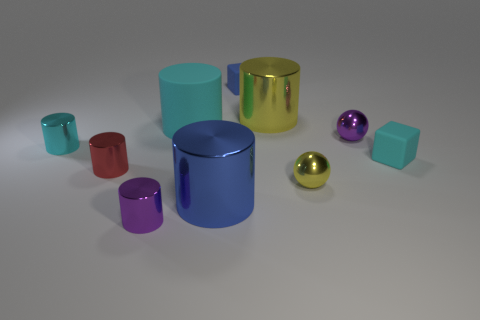There is a large matte cylinder; is it the same color as the small cylinder behind the cyan rubber cube?
Offer a terse response. Yes. Do the blue rubber block and the yellow cylinder have the same size?
Provide a succinct answer. No. There is a tiny yellow thing that is the same material as the tiny purple sphere; what shape is it?
Your answer should be compact. Sphere. What number of other things are there of the same shape as the blue matte thing?
Provide a succinct answer. 1. There is a small purple metal object that is to the left of the small purple object that is right of the small purple thing that is in front of the tiny cyan cylinder; what is its shape?
Your answer should be very brief. Cylinder. What number of cylinders are shiny things or blue matte objects?
Keep it short and to the point. 5. Is there a purple object that is on the right side of the metal cylinder right of the large blue metallic cylinder?
Ensure brevity in your answer.  Yes. Is there any other thing that is made of the same material as the small purple sphere?
Make the answer very short. Yes. Do the tiny blue rubber object and the metallic object behind the large cyan matte thing have the same shape?
Provide a short and direct response. No. How many other things are the same size as the rubber cylinder?
Keep it short and to the point. 2. 